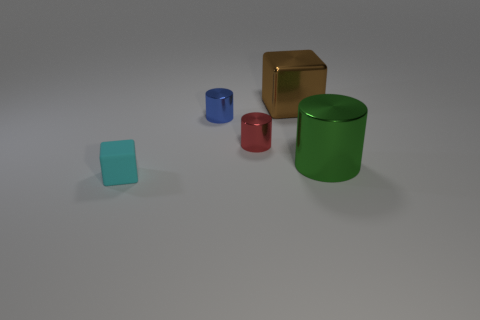The cylinder left of the tiny red metal object on the left side of the large shiny thing behind the big cylinder is made of what material?
Make the answer very short. Metal. There is a thing left of the small blue cylinder; is its shape the same as the large thing that is to the left of the big green metal cylinder?
Your response must be concise. Yes. What number of other objects are there of the same material as the tiny cyan object?
Your response must be concise. 0. Is the material of the cube that is behind the cyan rubber cube the same as the big thing that is in front of the blue shiny thing?
Offer a very short reply. Yes. There is a blue object that is made of the same material as the big brown object; what is its shape?
Your response must be concise. Cylinder. Are there any other things of the same color as the tiny matte thing?
Your response must be concise. No. What number of tiny red metallic objects are there?
Offer a terse response. 1. There is a object that is in front of the red object and left of the big green cylinder; what shape is it?
Give a very brief answer. Cube. What is the shape of the tiny thing that is on the right side of the blue cylinder that is in front of the cube that is right of the tiny matte object?
Provide a short and direct response. Cylinder. There is a tiny object that is behind the cyan rubber object and in front of the blue cylinder; what material is it?
Give a very brief answer. Metal. 